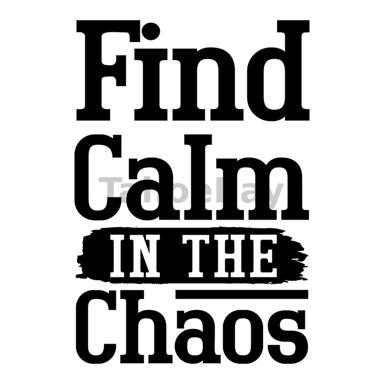How might this message be relevant in everyday life? The message 'Find Calm IN THE Chaos' holds significant relevance in everyday life, especially considering the modern world's fast-paced and often unpredictable nature. From managing deadlines and familial responsibilities to navigating personal struggles, finding calm in the chaos can serve as a coping mechanism to enhance emotional and mental resilience. Implementing this philosophy can involve practices like meditation, deep breathing exercises, or simply taking mindful moments to reflect and find grounding amidst busy schedules, thereby promoting a healthier, more balanced lifestyle. 